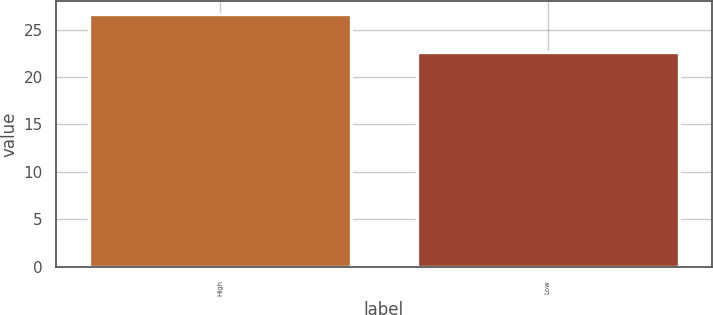Convert chart. <chart><loc_0><loc_0><loc_500><loc_500><bar_chart><fcel>High<fcel>Low<nl><fcel>26.68<fcel>22.7<nl></chart> 